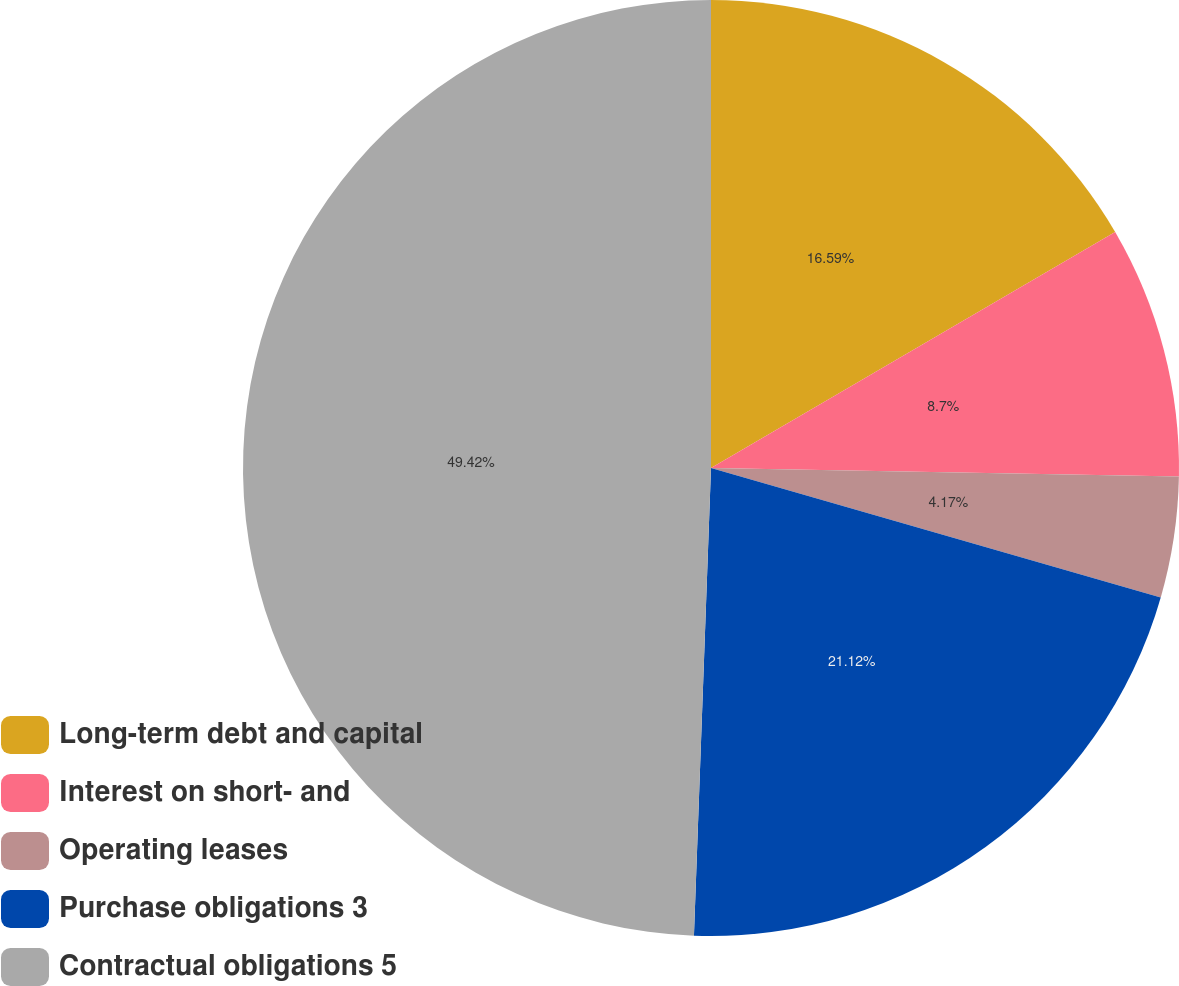<chart> <loc_0><loc_0><loc_500><loc_500><pie_chart><fcel>Long-term debt and capital<fcel>Interest on short- and<fcel>Operating leases<fcel>Purchase obligations 3<fcel>Contractual obligations 5<nl><fcel>16.59%<fcel>8.7%<fcel>4.17%<fcel>21.12%<fcel>49.42%<nl></chart> 